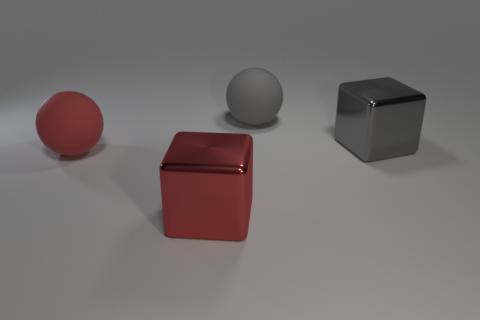Add 2 red rubber spheres. How many objects exist? 6 Add 2 large gray cubes. How many large gray cubes are left? 3 Add 4 metal blocks. How many metal blocks exist? 6 Subtract 0 red cylinders. How many objects are left? 4 Subtract all metal blocks. Subtract all big red metal cubes. How many objects are left? 1 